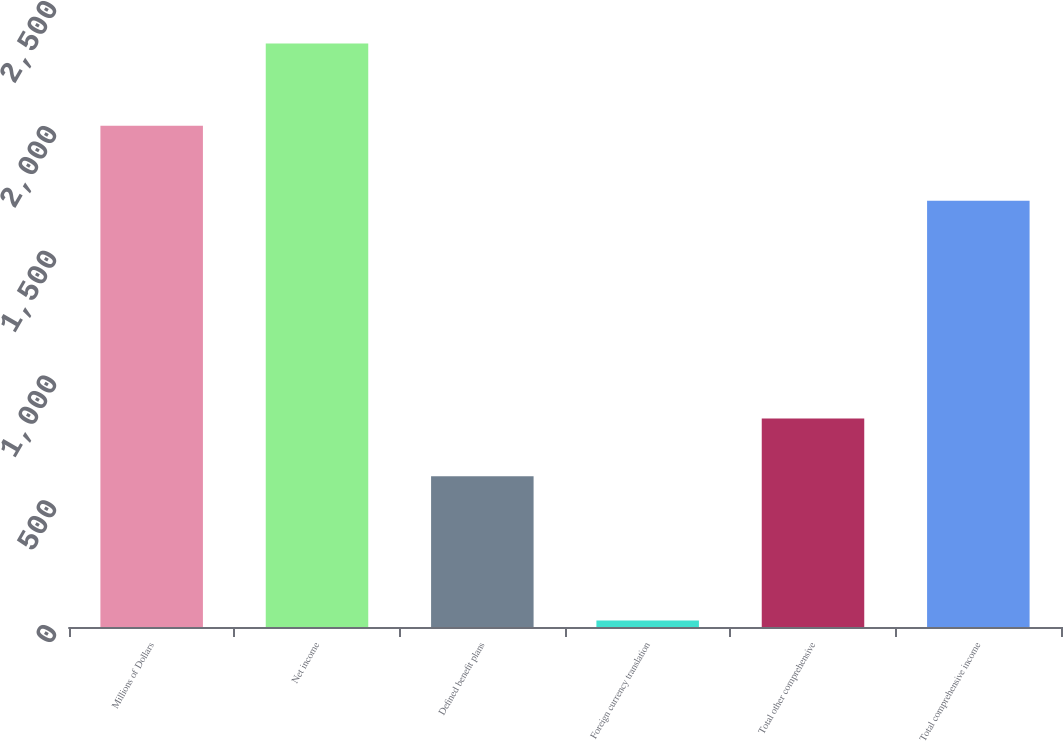Convert chart. <chart><loc_0><loc_0><loc_500><loc_500><bar_chart><fcel>Millions of Dollars<fcel>Net income<fcel>Defined benefit plans<fcel>Foreign currency translation<fcel>Total other comprehensive<fcel>Total comprehensive income<nl><fcel>2008<fcel>2338<fcel>604<fcel>26<fcel>835.2<fcel>1708<nl></chart> 